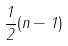<formula> <loc_0><loc_0><loc_500><loc_500>\frac { 1 } { 2 } ( n - 1 )</formula> 